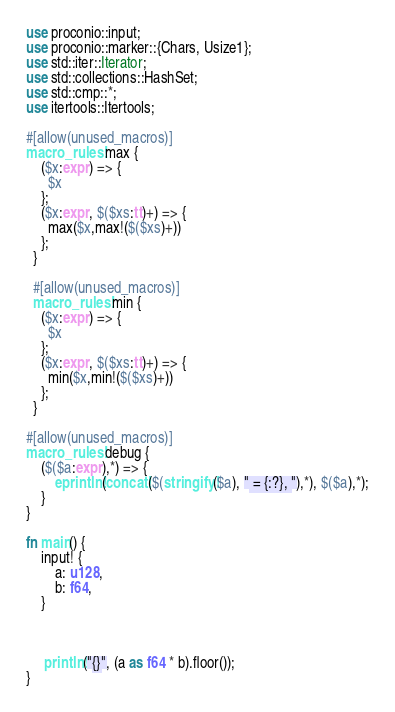Convert code to text. <code><loc_0><loc_0><loc_500><loc_500><_Rust_>use proconio::input;
use proconio::marker::{Chars, Usize1};
use std::iter::Iterator;
use std::collections::HashSet;
use std::cmp::*;
use itertools::Itertools;

#[allow(unused_macros)]
macro_rules! max {
    ($x:expr) => {
      $x
    };
    ($x:expr, $($xs:tt)+) => {
      max($x,max!($($xs)+))
    };
  }
  
  #[allow(unused_macros)]
  macro_rules! min {
    ($x:expr) => {
      $x
    };
    ($x:expr, $($xs:tt)+) => {
      min($x,min!($($xs)+))
    };
  }

#[allow(unused_macros)]
macro_rules! debug {
    ($($a:expr),*) => {
        eprintln!(concat!($(stringify!($a), " = {:?}, "),*), $($a),*);
    }
}

fn main() {
    input! {
        a: u128,
        b: f64,
    }



     println!("{}", (a as f64 * b).floor());
}
</code> 